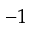<formula> <loc_0><loc_0><loc_500><loc_500>^ { - 1 }</formula> 